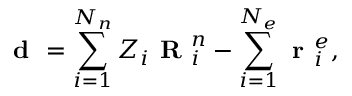Convert formula to latex. <formula><loc_0><loc_0><loc_500><loc_500>d = \sum _ { i = 1 } ^ { N _ { n } } Z _ { i } R _ { i } ^ { n } - \sum _ { i = 1 } ^ { N _ { e } } r _ { i } ^ { e } ,</formula> 